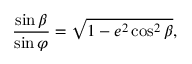Convert formula to latex. <formula><loc_0><loc_0><loc_500><loc_500>{ \frac { \sin \beta } { \sin \varphi } } = { \sqrt { 1 - e ^ { 2 } \cos ^ { 2 } \beta } } ,</formula> 